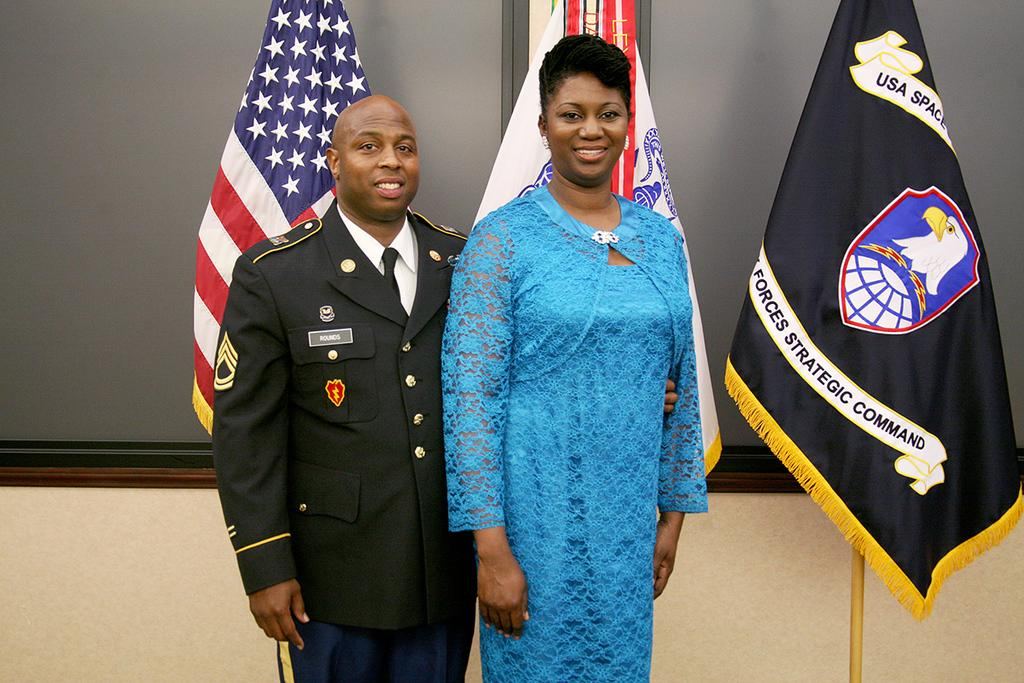<image>
Write a terse but informative summary of the picture. Uniform with a lighting badge and a Rounds name tag. 